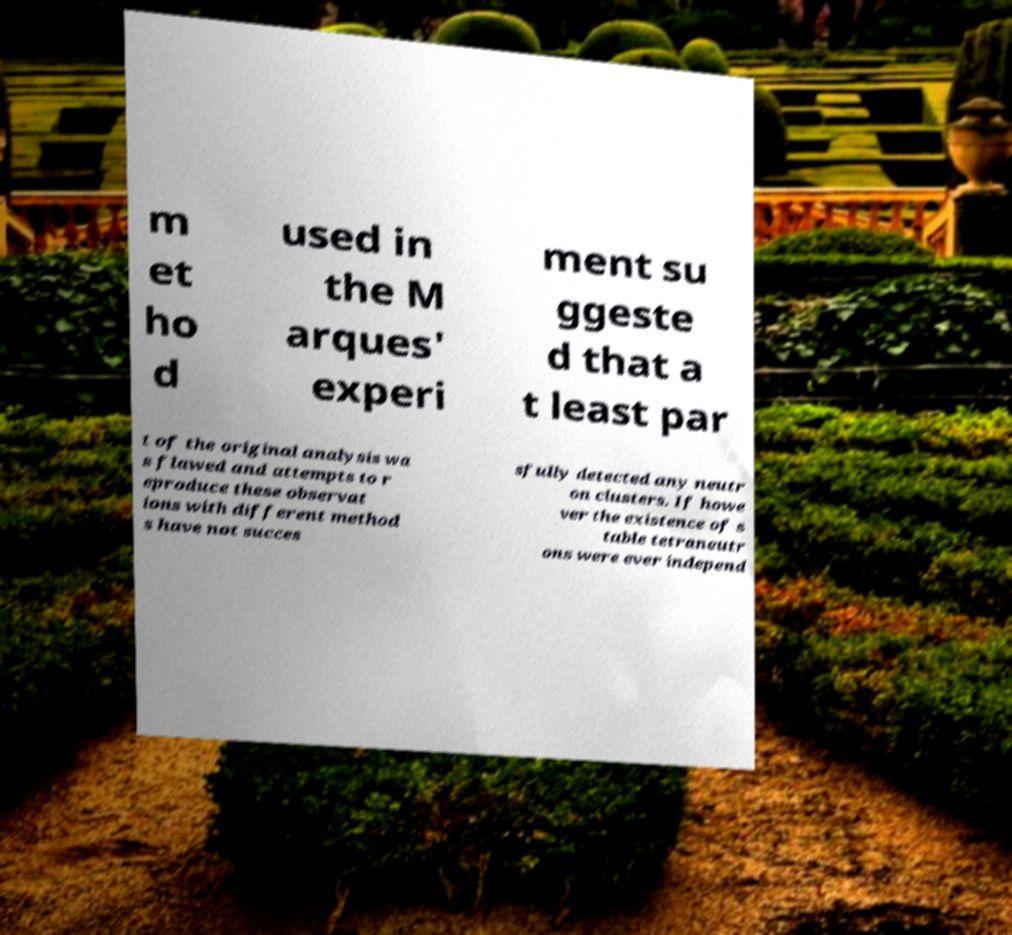Could you assist in decoding the text presented in this image and type it out clearly? m et ho d used in the M arques' experi ment su ggeste d that a t least par t of the original analysis wa s flawed and attempts to r eproduce these observat ions with different method s have not succes sfully detected any neutr on clusters. If howe ver the existence of s table tetraneutr ons were ever independ 